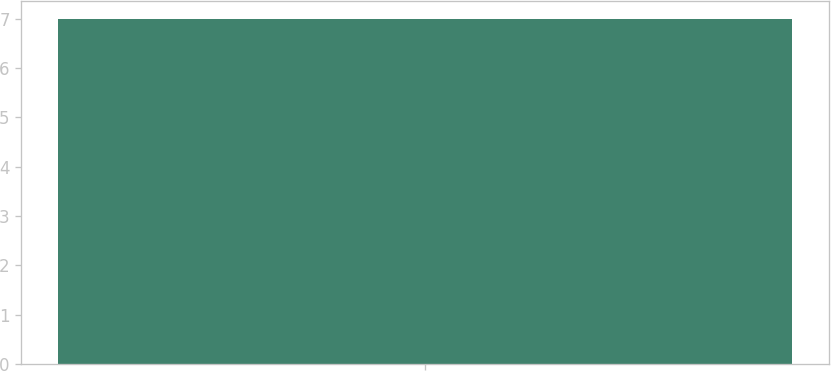<chart> <loc_0><loc_0><loc_500><loc_500><bar_chart><ecel><nl><fcel>7<nl></chart> 